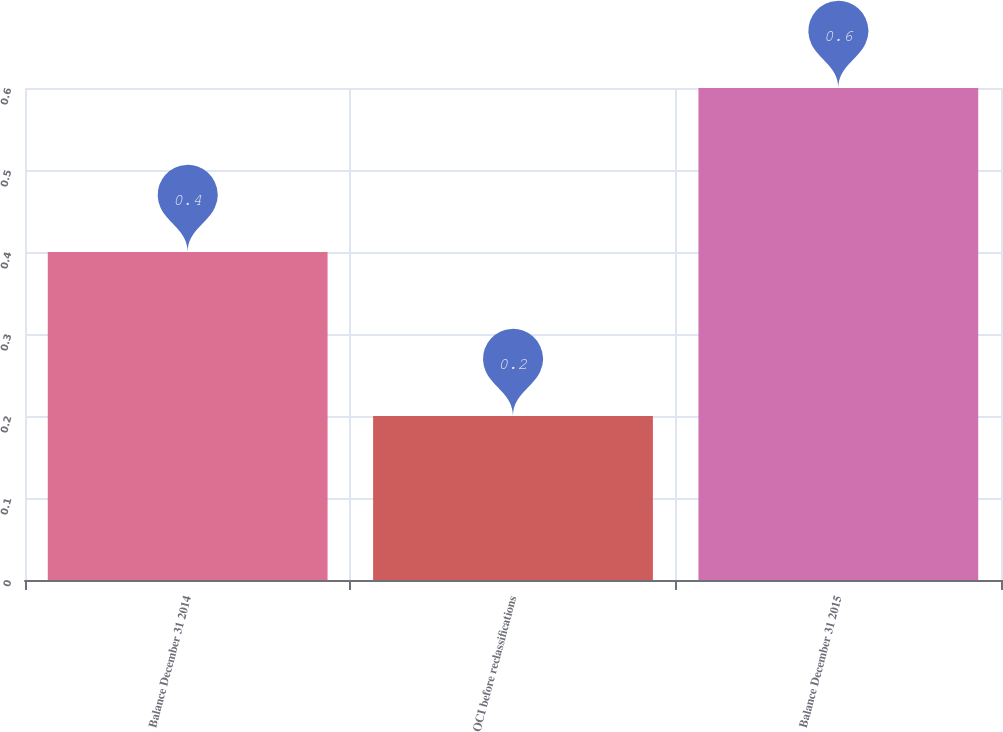<chart> <loc_0><loc_0><loc_500><loc_500><bar_chart><fcel>Balance December 31 2014<fcel>OCI before reclassifications<fcel>Balance December 31 2015<nl><fcel>0.4<fcel>0.2<fcel>0.6<nl></chart> 